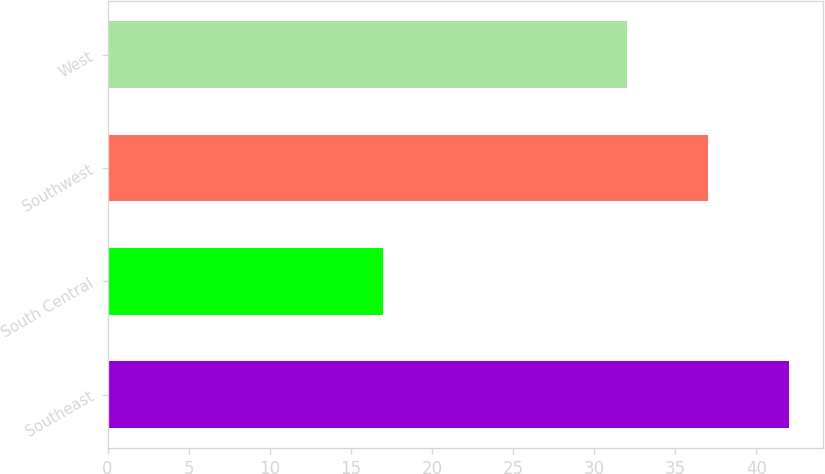Convert chart to OTSL. <chart><loc_0><loc_0><loc_500><loc_500><bar_chart><fcel>Southeast<fcel>South Central<fcel>Southwest<fcel>West<nl><fcel>42<fcel>17<fcel>37<fcel>32<nl></chart> 